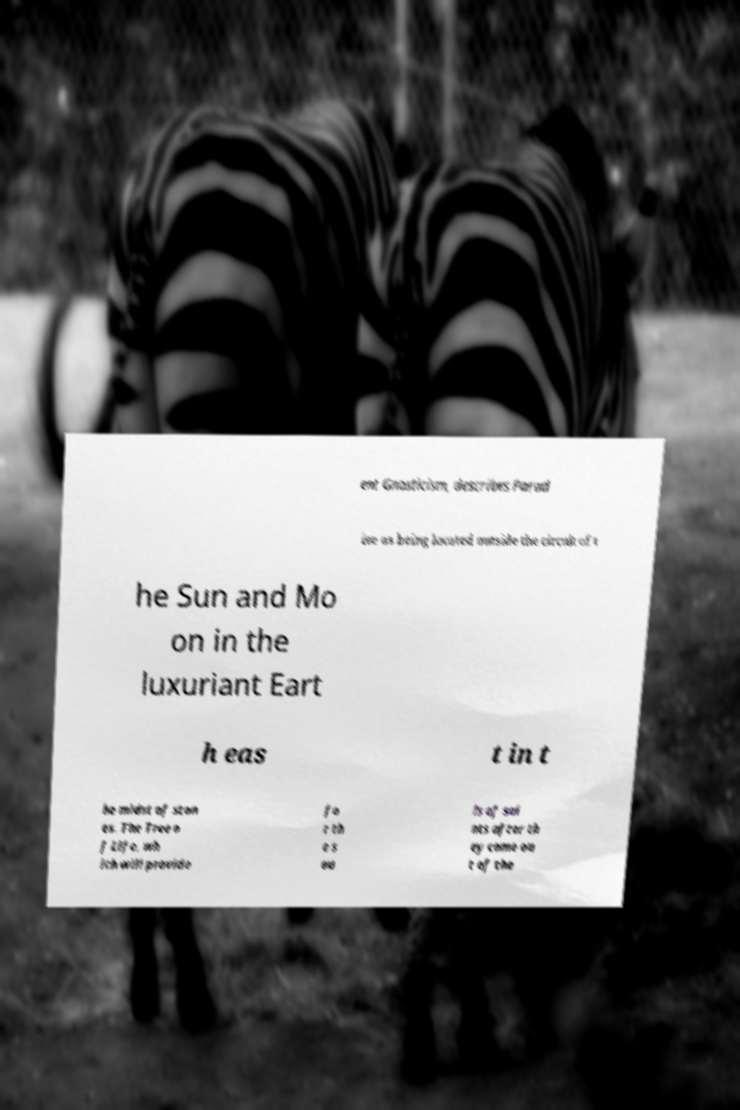Can you accurately transcribe the text from the provided image for me? ent Gnosticism, describes Parad ise as being located outside the circuit of t he Sun and Mo on in the luxuriant Eart h eas t in t he midst of ston es. The Tree o f Life, wh ich will provide fo r th e s ou ls of sai nts after th ey come ou t of the 